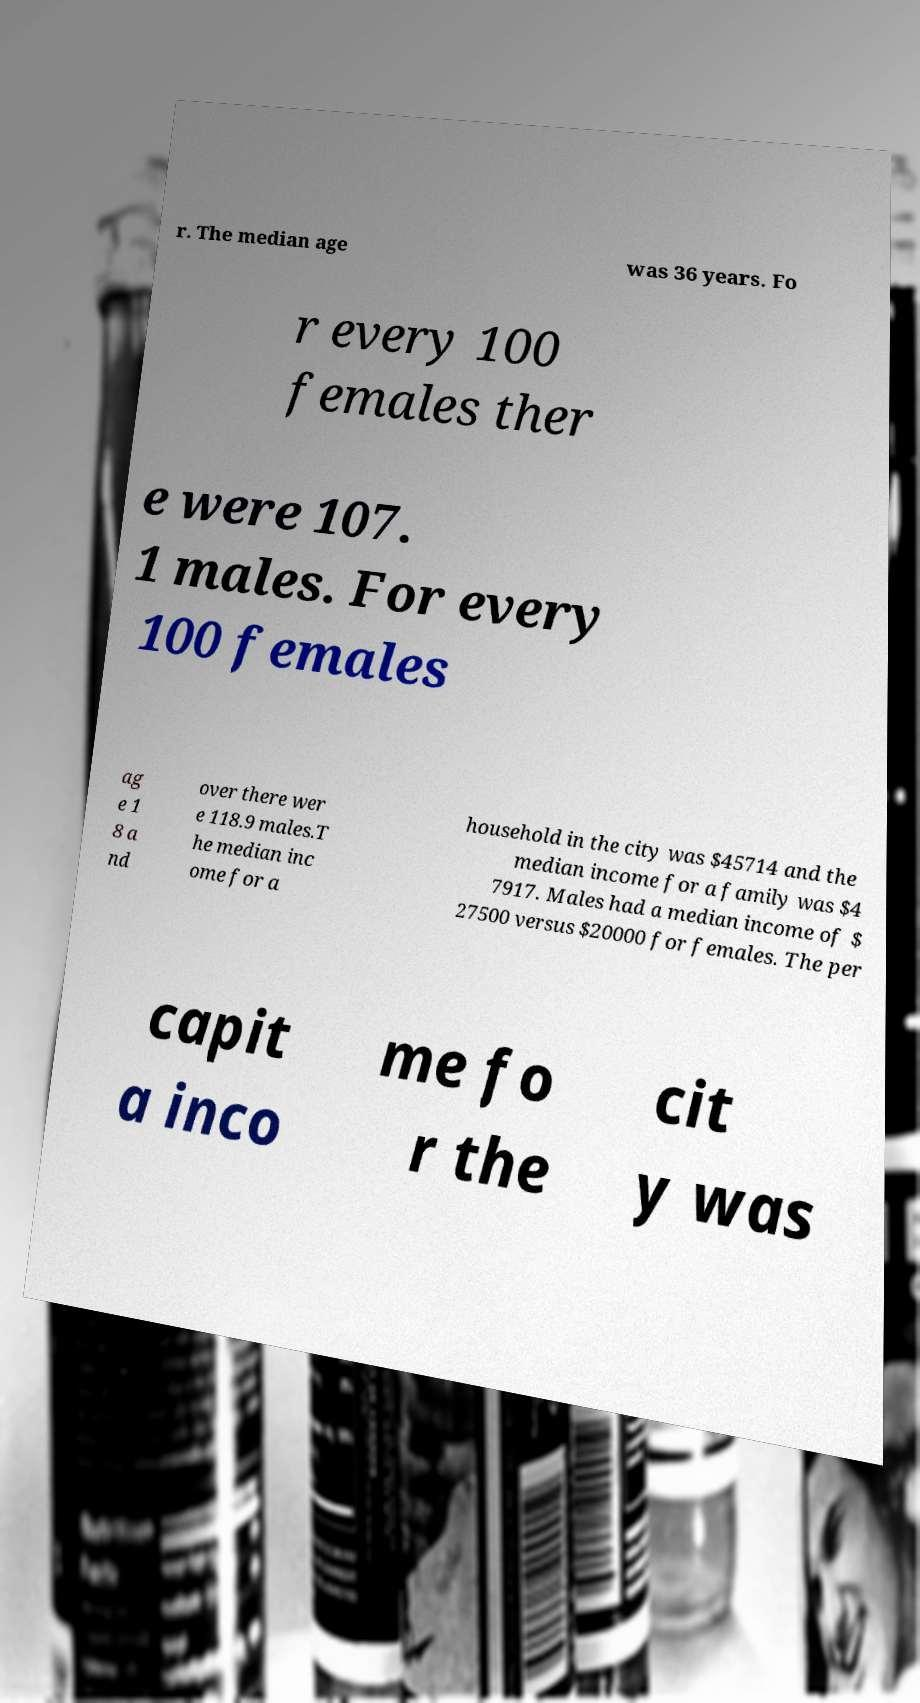Could you extract and type out the text from this image? r. The median age was 36 years. Fo r every 100 females ther e were 107. 1 males. For every 100 females ag e 1 8 a nd over there wer e 118.9 males.T he median inc ome for a household in the city was $45714 and the median income for a family was $4 7917. Males had a median income of $ 27500 versus $20000 for females. The per capit a inco me fo r the cit y was 